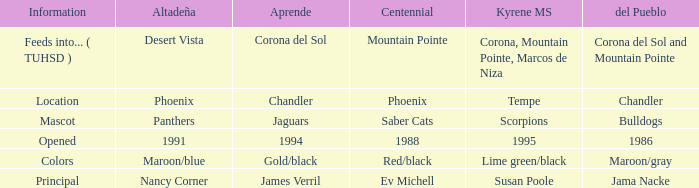WHich kind of Aprende has a Centennial of 1988? 1994.0. 